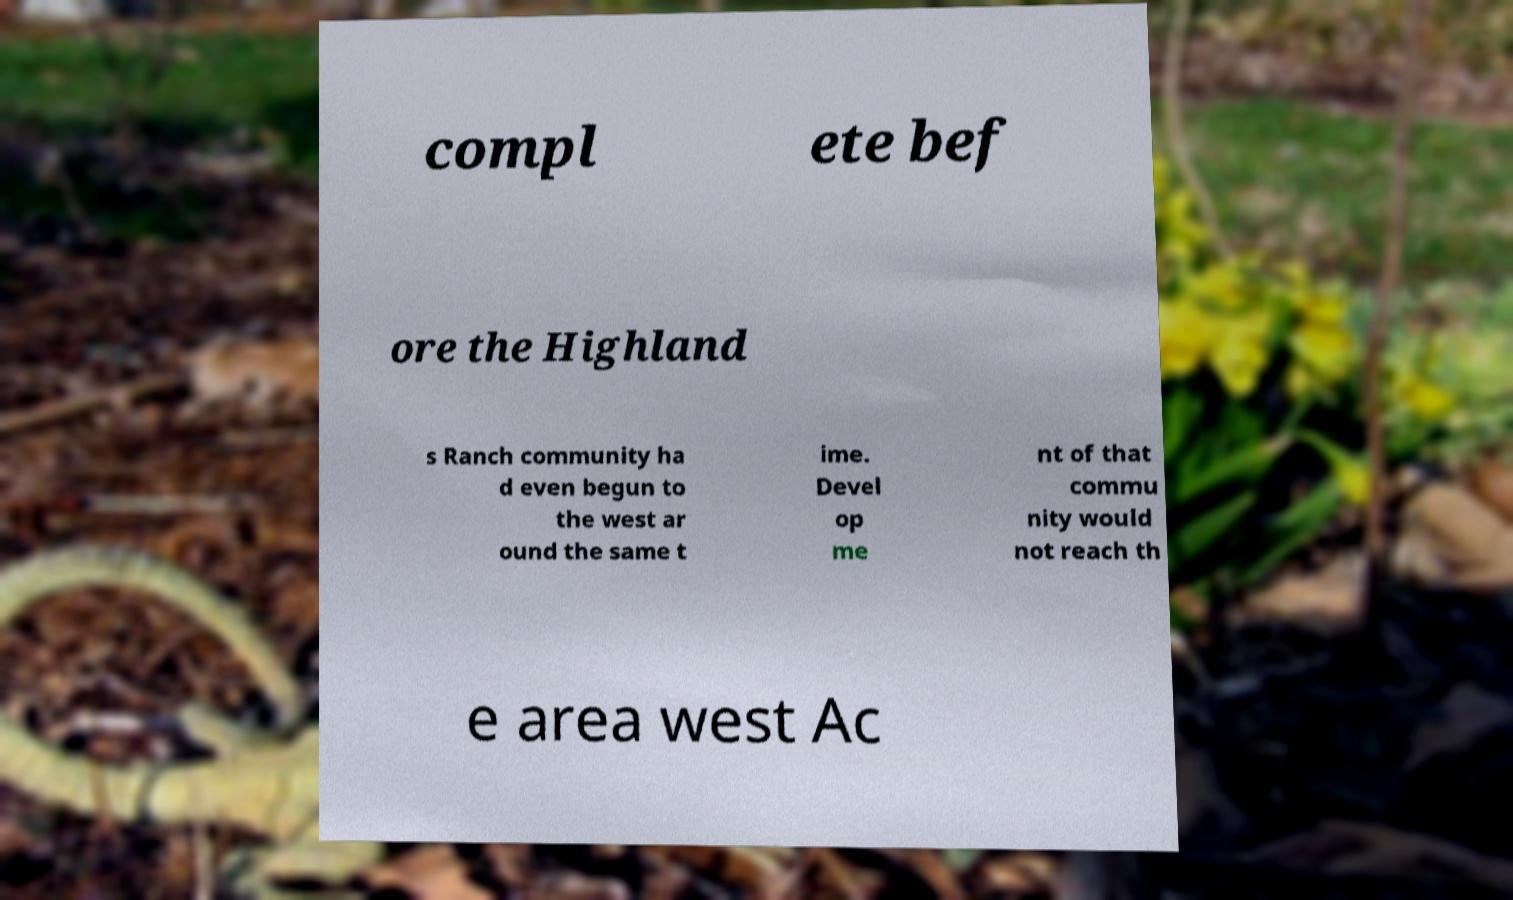Can you read and provide the text displayed in the image?This photo seems to have some interesting text. Can you extract and type it out for me? compl ete bef ore the Highland s Ranch community ha d even begun to the west ar ound the same t ime. Devel op me nt of that commu nity would not reach th e area west Ac 